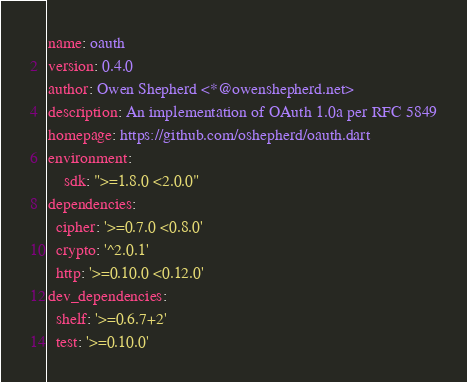Convert code to text. <code><loc_0><loc_0><loc_500><loc_500><_YAML_>name: oauth
version: 0.4.0
author: Owen Shepherd <*@owenshepherd.net>
description: An implementation of OAuth 1.0a per RFC 5849
homepage: https://github.com/oshepherd/oauth.dart
environment:
    sdk: ">=1.8.0 <2.0.0"
dependencies:
  cipher: '>=0.7.0 <0.8.0'
  crypto: '^2.0.1'
  http: '>=0.10.0 <0.12.0'
dev_dependencies:
  shelf: '>=0.6.7+2'
  test: '>=0.10.0'
</code> 